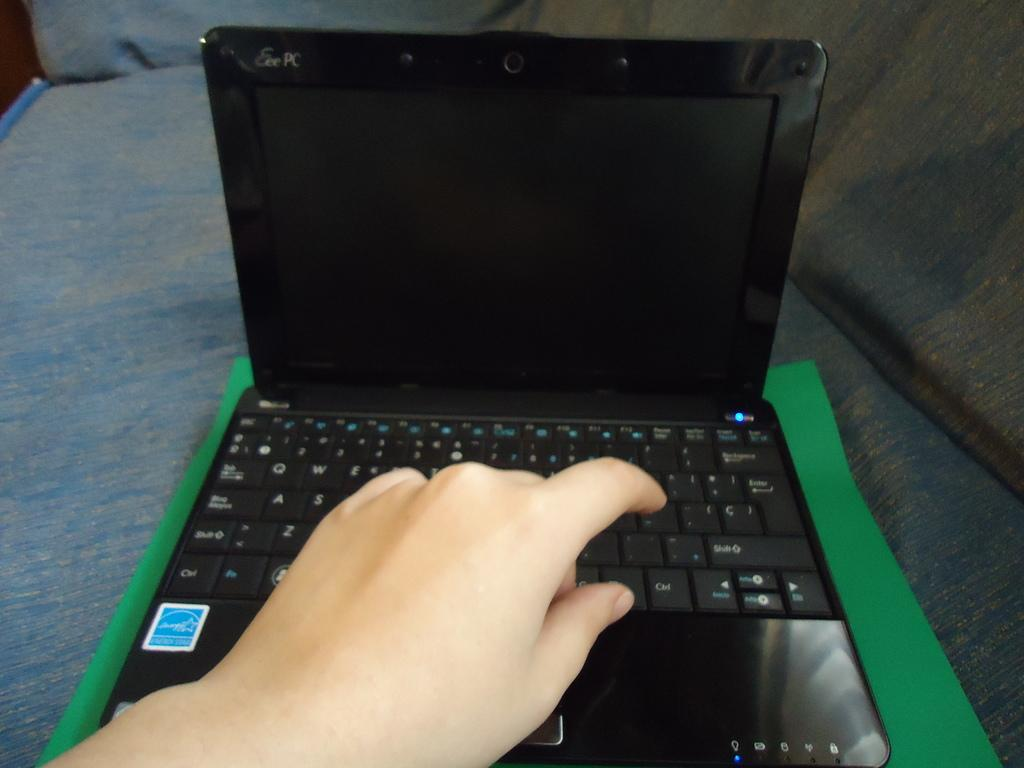<image>
Describe the image concisely. Black laptop computer open with Eee PC in the top left 